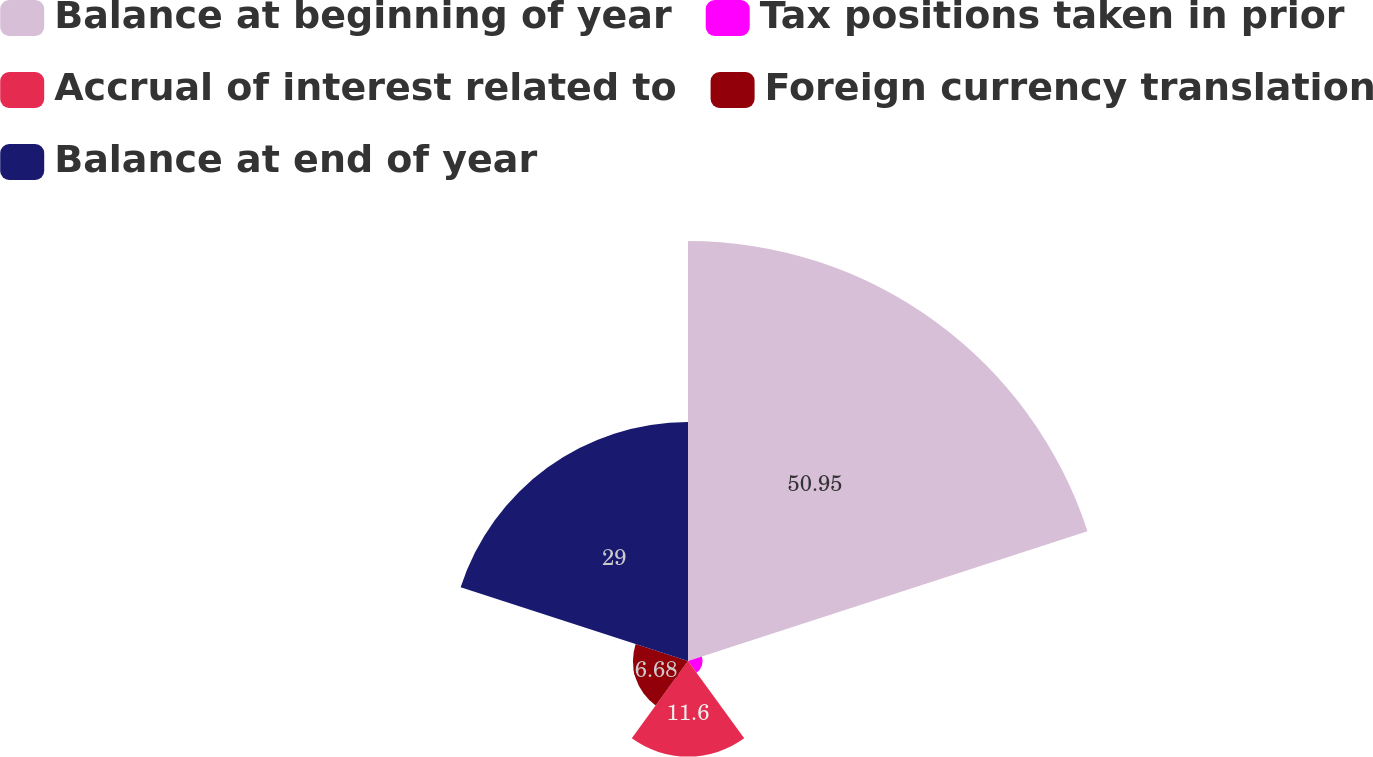Convert chart to OTSL. <chart><loc_0><loc_0><loc_500><loc_500><pie_chart><fcel>Balance at beginning of year<fcel>Tax positions taken in prior<fcel>Accrual of interest related to<fcel>Foreign currency translation<fcel>Balance at end of year<nl><fcel>50.95%<fcel>1.77%<fcel>11.6%<fcel>6.68%<fcel>29.0%<nl></chart> 